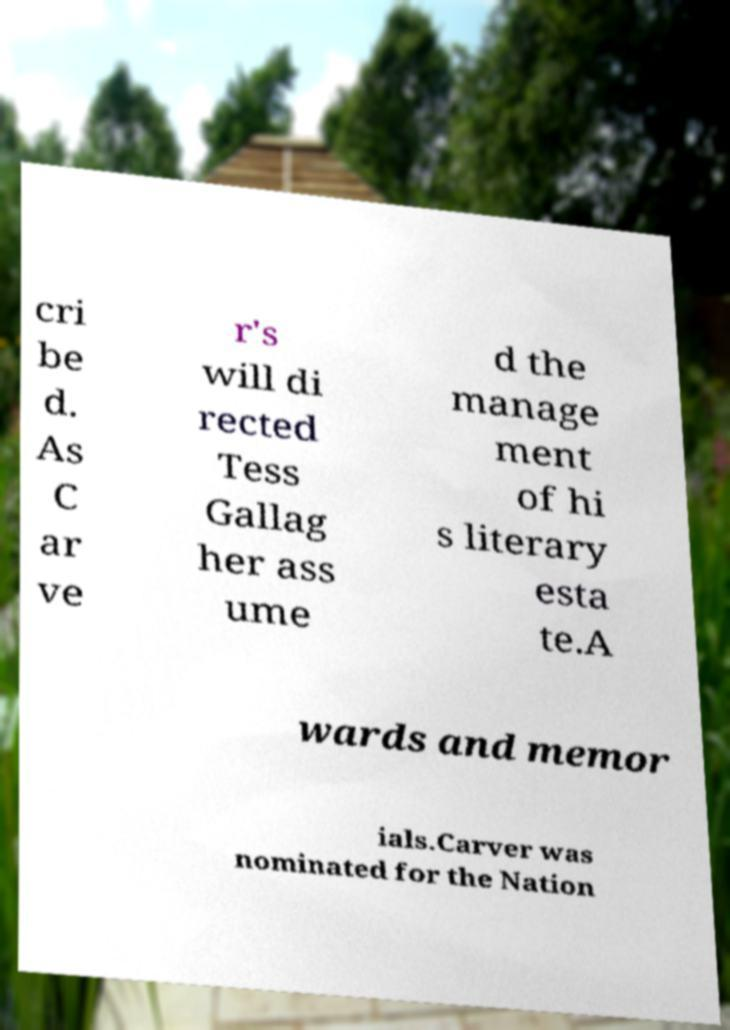Can you accurately transcribe the text from the provided image for me? cri be d. As C ar ve r's will di rected Tess Gallag her ass ume d the manage ment of hi s literary esta te.A wards and memor ials.Carver was nominated for the Nation 